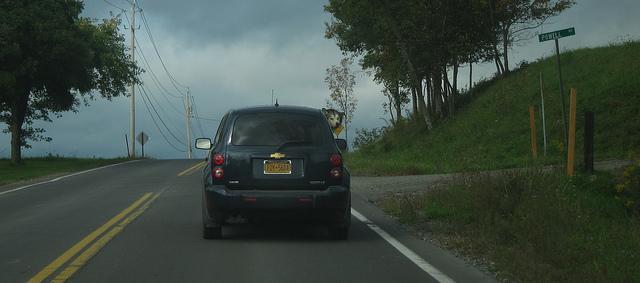How many cars are visible in this photo?
Give a very brief answer. 1. How many cars are there?
Give a very brief answer. 1. How many street signs are there?
Give a very brief answer. 3. 